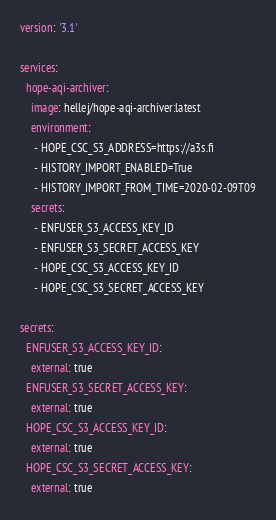<code> <loc_0><loc_0><loc_500><loc_500><_YAML_>version: '3.1'

services:
  hope-aqi-archiver:
    image: hellej/hope-aqi-archiver:latest
    environment:
     - HOPE_CSC_S3_ADDRESS=https://a3s.fi
     - HISTORY_IMPORT_ENABLED=True
     - HISTORY_IMPORT_FROM_TIME=2020-02-09T09
    secrets:
     - ENFUSER_S3_ACCESS_KEY_ID
     - ENFUSER_S3_SECRET_ACCESS_KEY
     - HOPE_CSC_S3_ACCESS_KEY_ID
     - HOPE_CSC_S3_SECRET_ACCESS_KEY

secrets:
  ENFUSER_S3_ACCESS_KEY_ID:
    external: true
  ENFUSER_S3_SECRET_ACCESS_KEY:
    external: true
  HOPE_CSC_S3_ACCESS_KEY_ID:
    external: true
  HOPE_CSC_S3_SECRET_ACCESS_KEY:
    external: true
</code> 